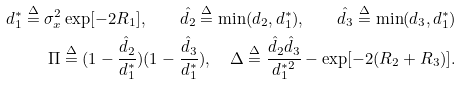Convert formula to latex. <formula><loc_0><loc_0><loc_500><loc_500>d _ { 1 } ^ { * } \stackrel { \Delta } { = } \sigma _ { x } ^ { 2 } \exp [ - 2 R _ { 1 } ] , \quad \hat { d _ { 2 } } \stackrel { \Delta } { = } \min ( d _ { 2 } , d _ { 1 } ^ { * } ) , \quad \hat { d _ { 3 } } \stackrel { \Delta } { = } \min ( d _ { 3 } , d _ { 1 } ^ { * } ) \\ \quad \Pi \stackrel { \Delta } { = } ( 1 - \frac { \hat { d } _ { 2 } } { d _ { 1 } ^ { * } } ) ( 1 - \frac { \hat { d } _ { 3 } } { d _ { 1 } ^ { * } } ) , \quad \Delta \stackrel { \Delta } { = } \frac { \hat { d } _ { 2 } \hat { d } _ { 3 } } { d _ { 1 } ^ { * 2 } } - \exp [ - 2 ( R _ { 2 } + R _ { 3 } ) ] .</formula> 